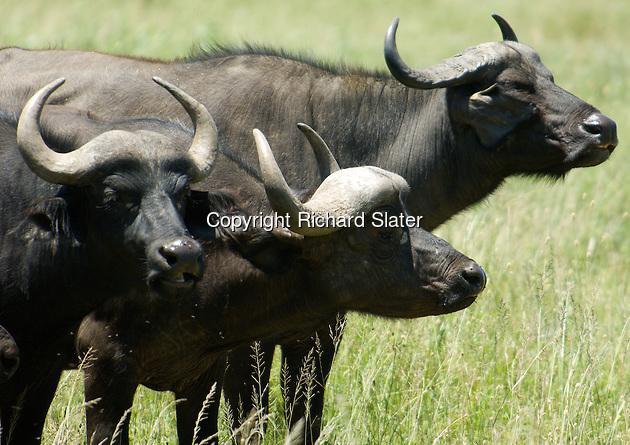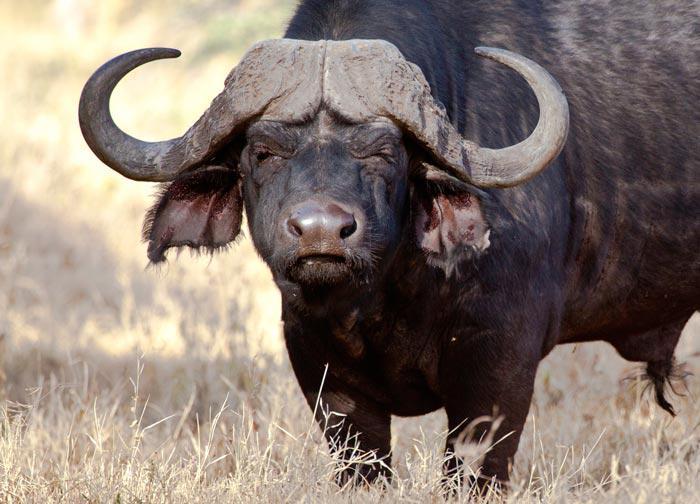The first image is the image on the left, the second image is the image on the right. Evaluate the accuracy of this statement regarding the images: "The cow in the image on the left is lying down.". Is it true? Answer yes or no. No. The first image is the image on the left, the second image is the image on the right. Considering the images on both sides, is "All water buffalo are standing, and one image contains multiple water buffalo." valid? Answer yes or no. Yes. 